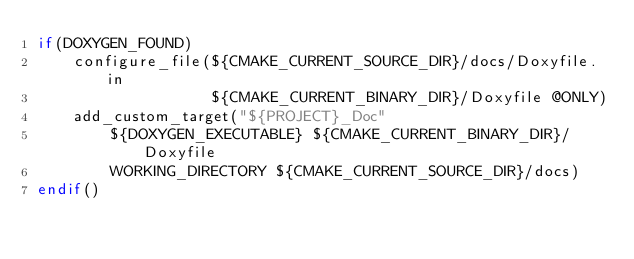Convert code to text. <code><loc_0><loc_0><loc_500><loc_500><_CMake_>if(DOXYGEN_FOUND)
    configure_file(${CMAKE_CURRENT_SOURCE_DIR}/docs/Doxyfile.in
                   ${CMAKE_CURRENT_BINARY_DIR}/Doxyfile @ONLY)
    add_custom_target("${PROJECT}_Doc"
        ${DOXYGEN_EXECUTABLE} ${CMAKE_CURRENT_BINARY_DIR}/Doxyfile
        WORKING_DIRECTORY ${CMAKE_CURRENT_SOURCE_DIR}/docs)
endif()</code> 